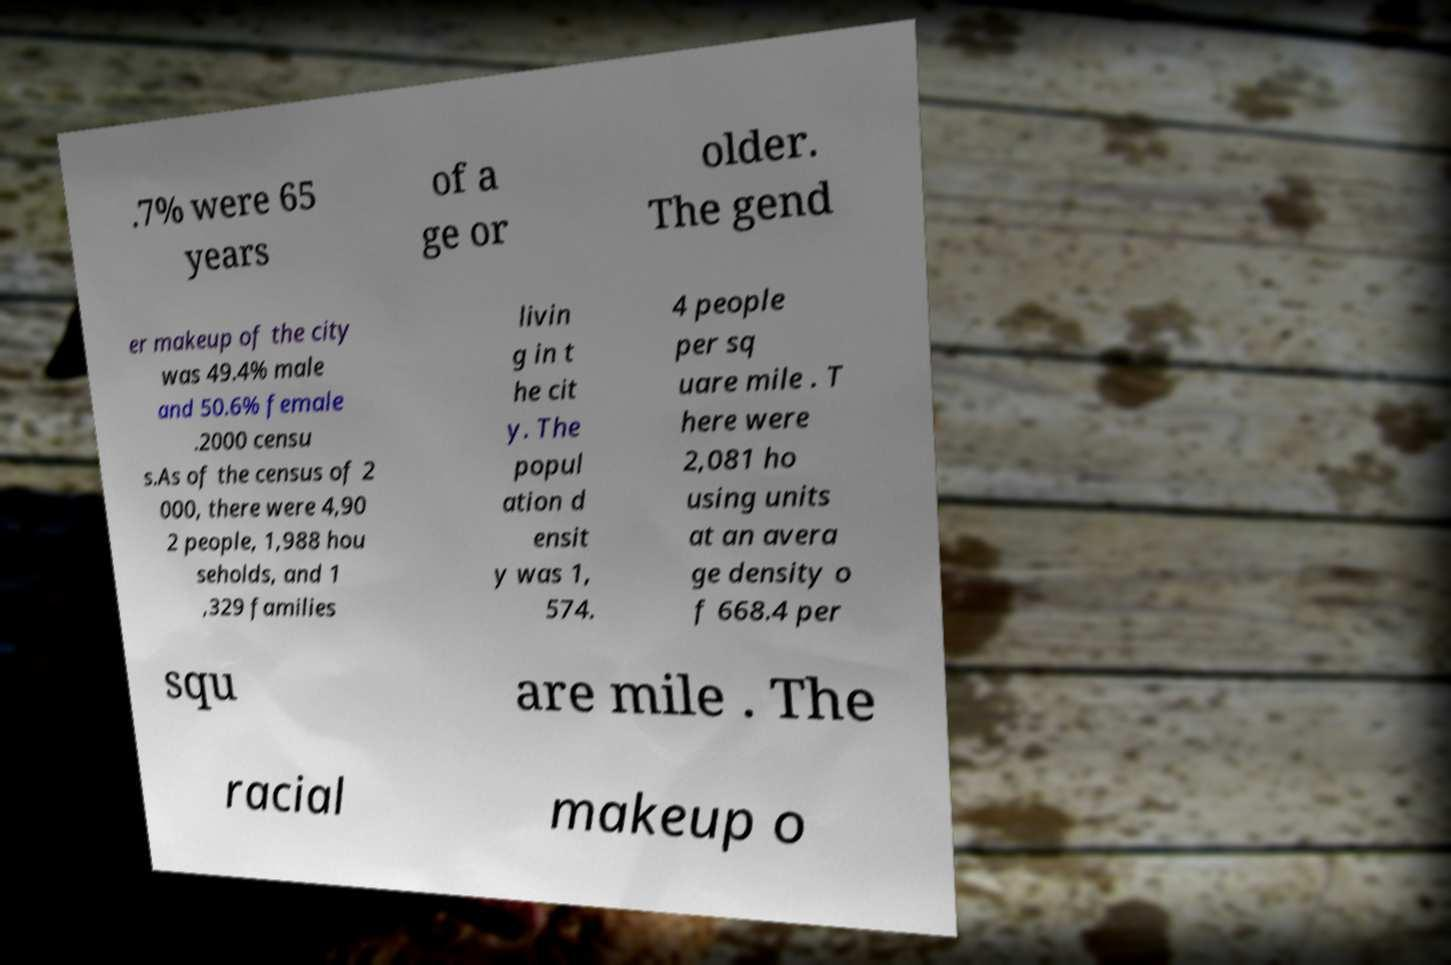I need the written content from this picture converted into text. Can you do that? .7% were 65 years of a ge or older. The gend er makeup of the city was 49.4% male and 50.6% female .2000 censu s.As of the census of 2 000, there were 4,90 2 people, 1,988 hou seholds, and 1 ,329 families livin g in t he cit y. The popul ation d ensit y was 1, 574. 4 people per sq uare mile . T here were 2,081 ho using units at an avera ge density o f 668.4 per squ are mile . The racial makeup o 